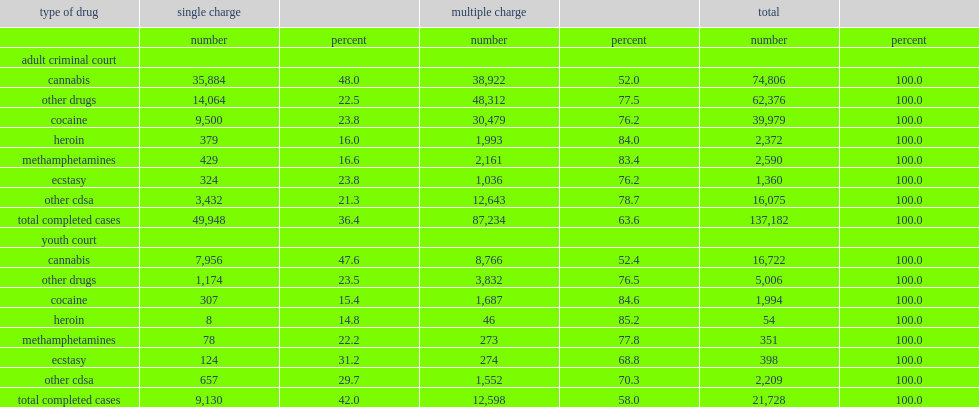For completed cases involving drugs other, what is the percentage of adult cases involved a single charge, from 2008/2009 to 2011/2012 in canada? 22.5. For completed cases involving drugs other, what is the percentage of youth cases involved a single charge, from 2008/2009 to 2011/2012 in canada? 47.6. 